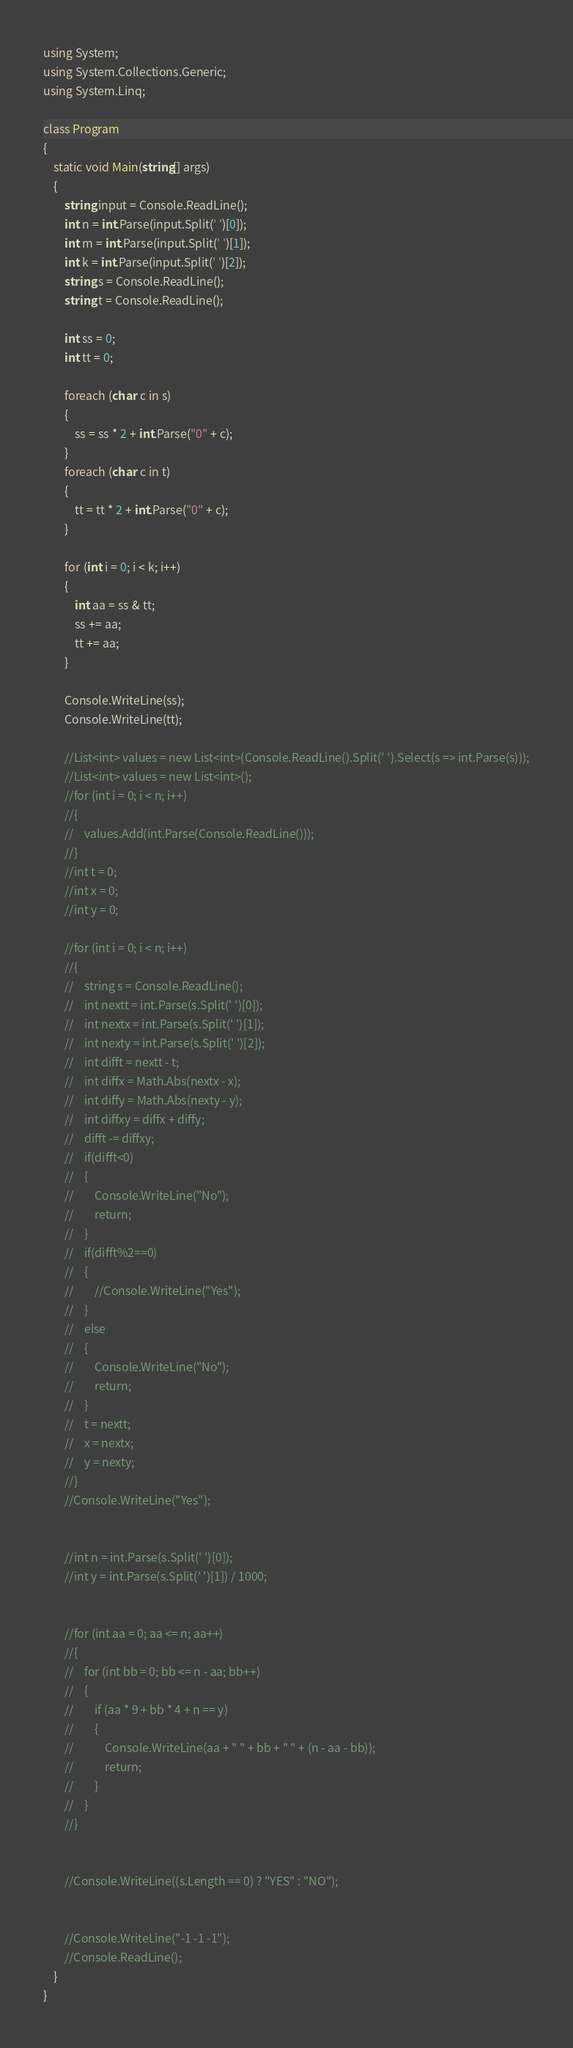<code> <loc_0><loc_0><loc_500><loc_500><_C#_>

using System;
using System.Collections.Generic;
using System.Linq;

class Program
{
    static void Main(string[] args)
    {
        string input = Console.ReadLine();
        int n = int.Parse(input.Split(' ')[0]);
        int m = int.Parse(input.Split(' ')[1]);
        int k = int.Parse(input.Split(' ')[2]);
        string s = Console.ReadLine();
        string t = Console.ReadLine();

        int ss = 0;
        int tt = 0;

        foreach (char c in s)
        {
            ss = ss * 2 + int.Parse("0" + c);
        }
        foreach (char c in t)
        {
            tt = tt * 2 + int.Parse("0" + c);
        }

        for (int i = 0; i < k; i++)
        {
            int aa = ss & tt;
            ss += aa;
            tt += aa;
        }

        Console.WriteLine(ss);
        Console.WriteLine(tt);

        //List<int> values = new List<int>(Console.ReadLine().Split(' ').Select(s => int.Parse(s)));
        //List<int> values = new List<int>();
        //for (int i = 0; i < n; i++)
        //{
        //    values.Add(int.Parse(Console.ReadLine()));
        //}
        //int t = 0;
        //int x = 0;
        //int y = 0;

        //for (int i = 0; i < n; i++)
        //{
        //    string s = Console.ReadLine();
        //    int nextt = int.Parse(s.Split(' ')[0]);
        //    int nextx = int.Parse(s.Split(' ')[1]);
        //    int nexty = int.Parse(s.Split(' ')[2]);
        //    int difft = nextt - t;
        //    int diffx = Math.Abs(nextx - x);
        //    int diffy = Math.Abs(nexty - y);
        //    int diffxy = diffx + diffy;
        //    difft -= diffxy;
        //    if(difft<0)
        //    {
        //        Console.WriteLine("No");
        //        return;
        //    }
        //    if(difft%2==0)
        //    {
        //        //Console.WriteLine("Yes");
        //    }
        //    else
        //    {
        //        Console.WriteLine("No");
        //        return;
        //    }
        //    t = nextt;
        //    x = nextx;
        //    y = nexty;
        //}
        //Console.WriteLine("Yes");


        //int n = int.Parse(s.Split(' ')[0]);
        //int y = int.Parse(s.Split(' ')[1]) / 1000;


        //for (int aa = 0; aa <= n; aa++)
        //{
        //    for (int bb = 0; bb <= n - aa; bb++)
        //    {
        //        if (aa * 9 + bb * 4 + n == y)
        //        {
        //            Console.WriteLine(aa + " " + bb + " " + (n - aa - bb));
        //            return;
        //        }
        //    }
        //}


        //Console.WriteLine((s.Length == 0) ? "YES" : "NO");


        //Console.WriteLine("-1 -1 -1");
        //Console.ReadLine();
    }
}</code> 